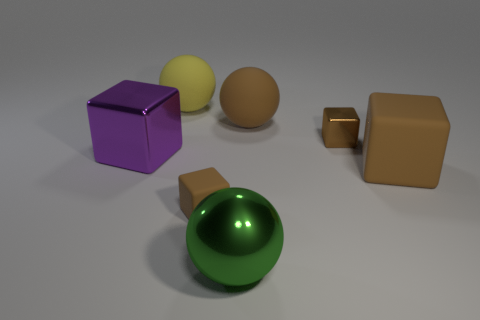Subtract all large brown balls. How many balls are left? 2 Add 2 large metallic blocks. How many objects exist? 9 Subtract all brown spheres. How many spheres are left? 2 Add 6 big brown matte things. How many big brown matte things are left? 8 Add 4 small shiny things. How many small shiny things exist? 5 Subtract 0 red blocks. How many objects are left? 7 Subtract all spheres. How many objects are left? 4 Subtract 4 blocks. How many blocks are left? 0 Subtract all blue blocks. Subtract all purple cylinders. How many blocks are left? 4 Subtract all purple spheres. How many gray cubes are left? 0 